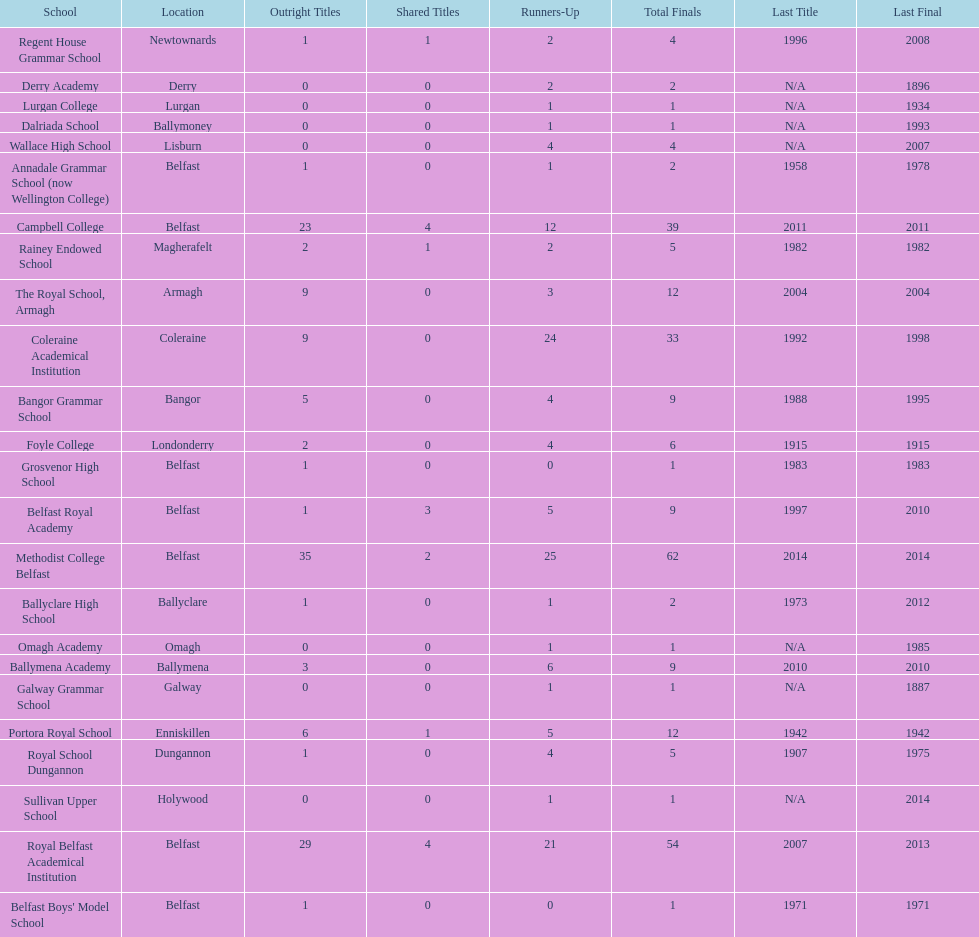Which school has the same number of outright titles as the coleraine academical institution? The Royal School, Armagh. 